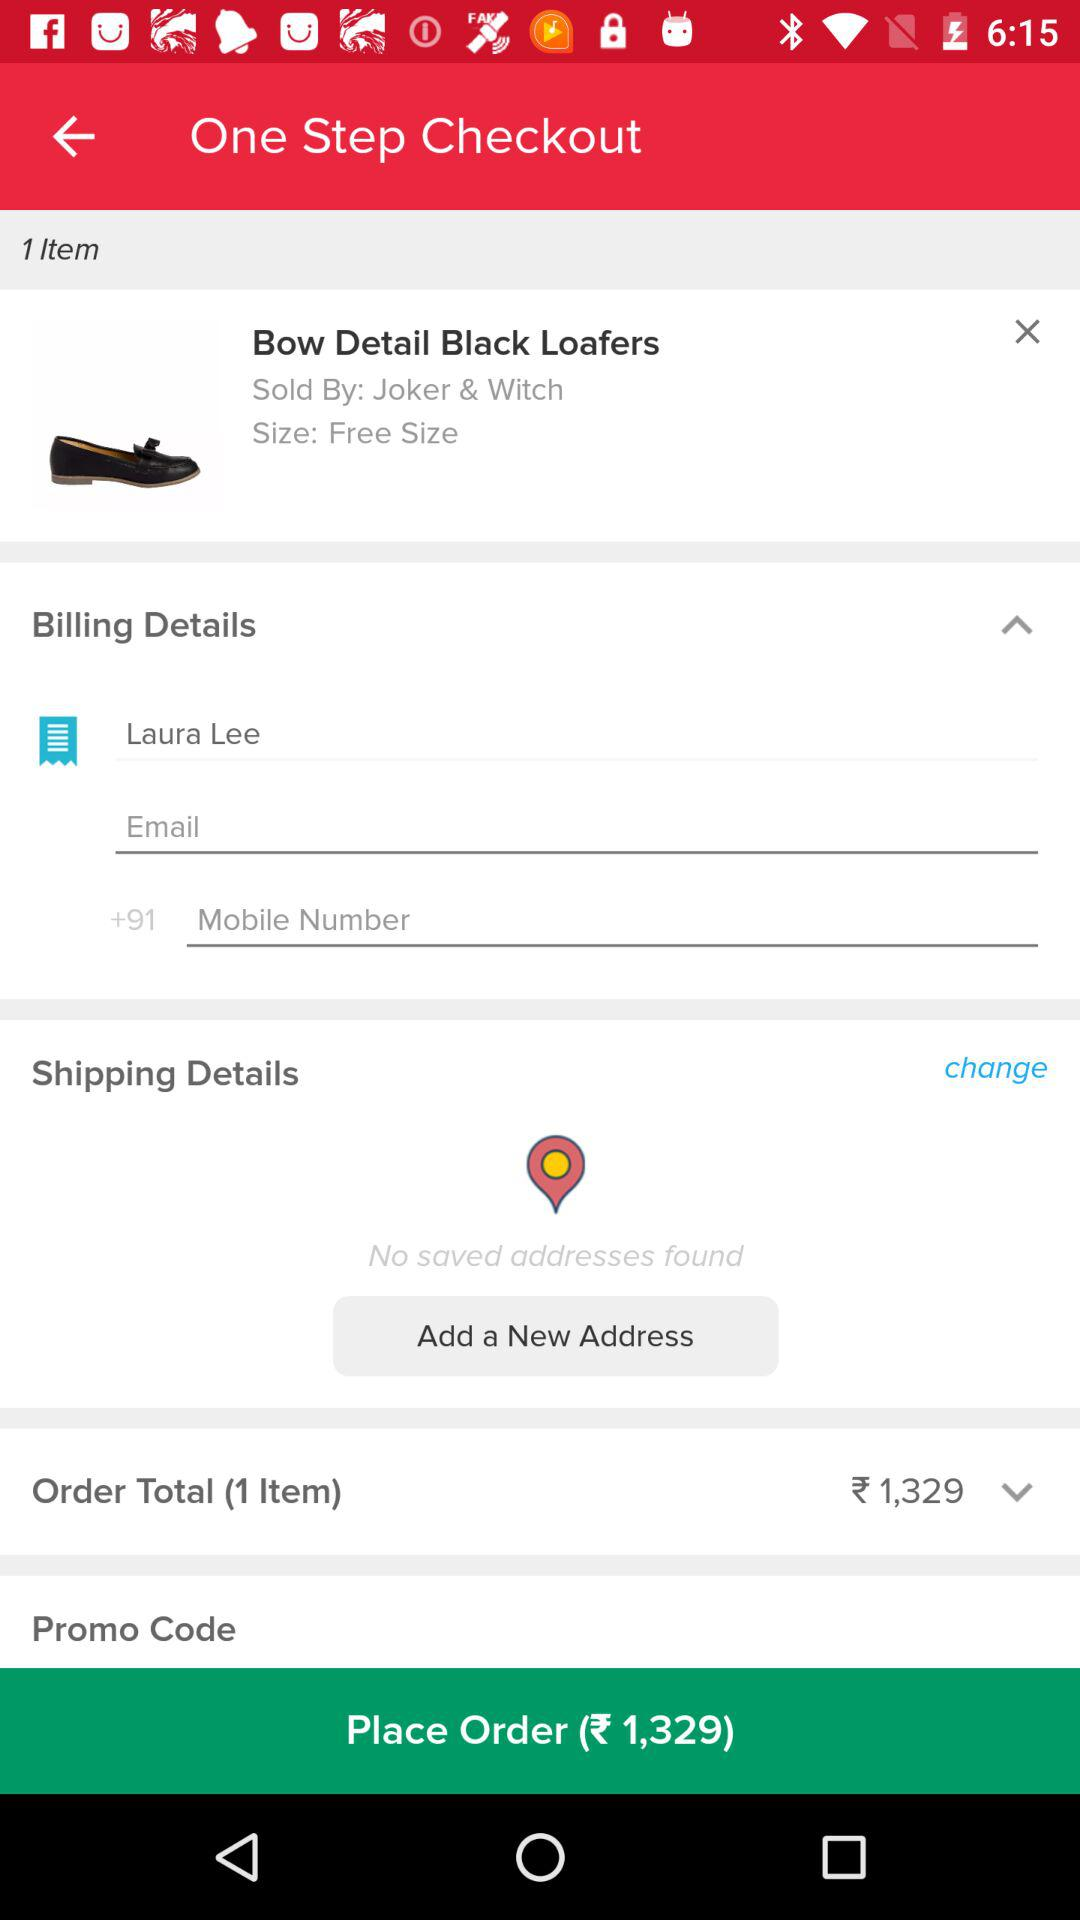By whom are "Bow Detail Black Loafers" sold? "Bow Detail Black Loafers" are sold by "Joker & Witch". 